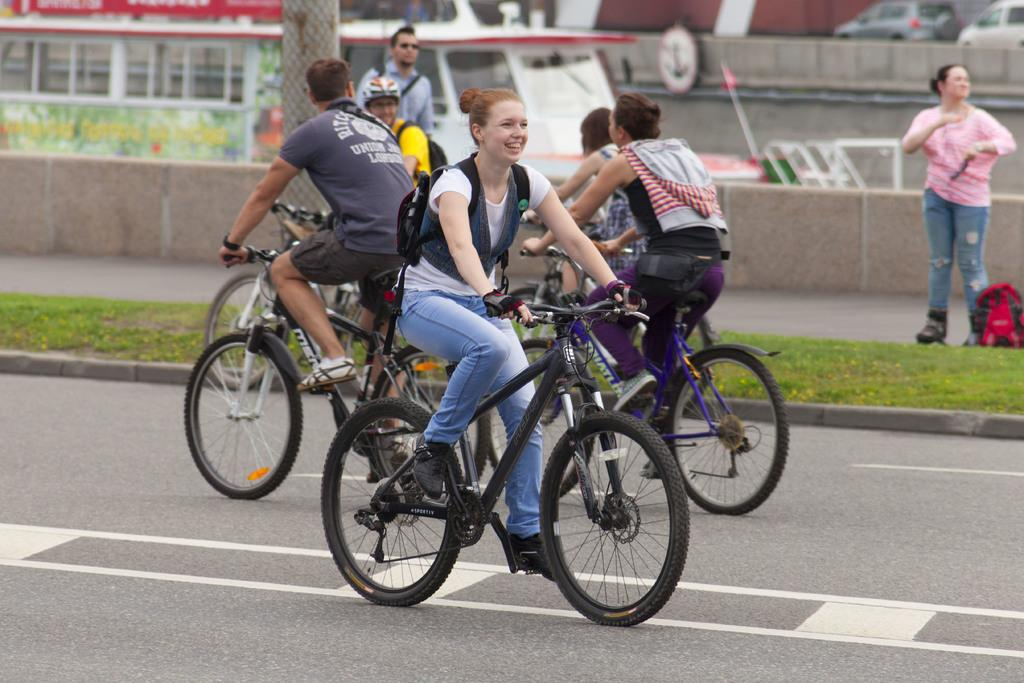What are the people in the image doing? There is a group of people riding bicycles on the road. What can be seen alongside the road? There is grass alongside the road. Are there any individuals standing near the road? Yes, there is a woman and a man standing near the road. What structures are near the road? There is a pillar and a bus near the road. What type of stone can be seen being carried by the woman in the image? There is no woman carrying a stone in the image; she is standing near the road. What song is being sung by the group of people riding bicycles in the image? There is no indication of any singing or music in the image; the group of people is simply riding bicycles. 